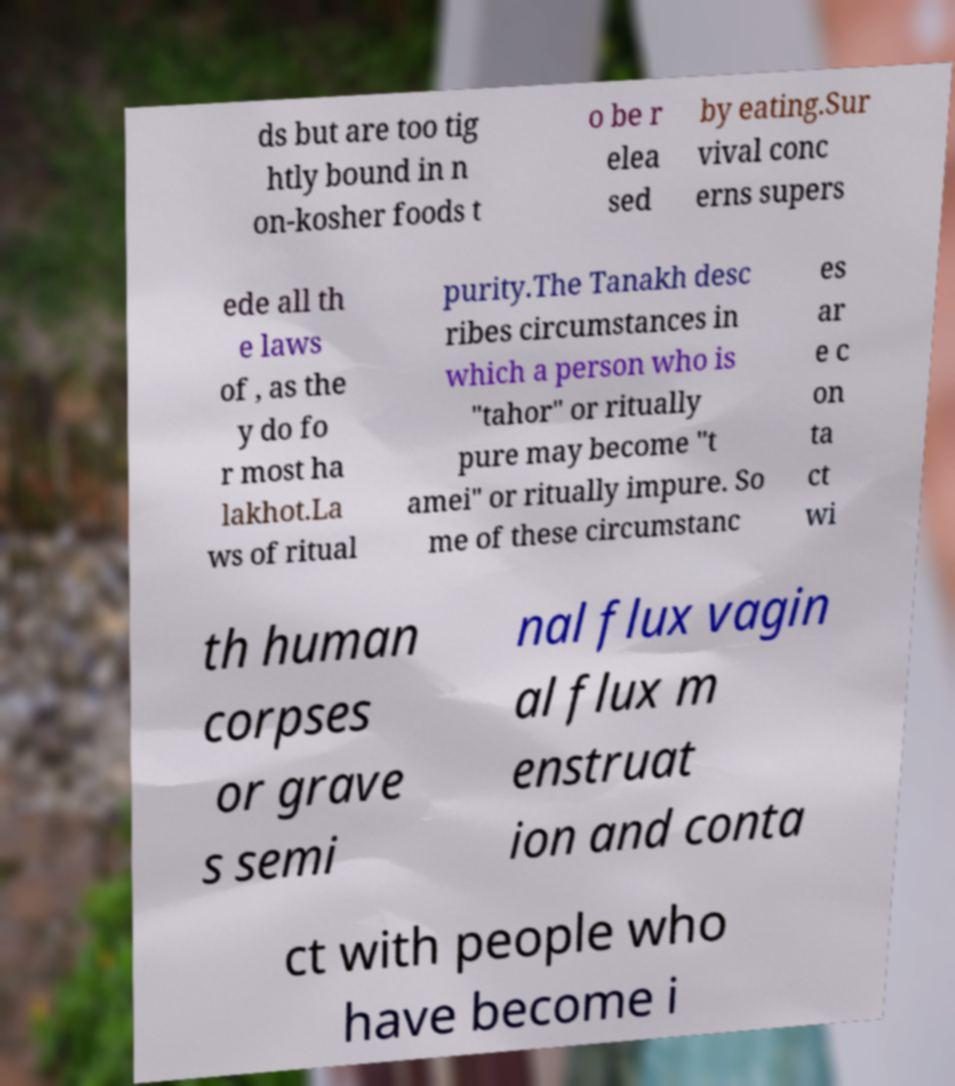I need the written content from this picture converted into text. Can you do that? ds but are too tig htly bound in n on-kosher foods t o be r elea sed by eating.Sur vival conc erns supers ede all th e laws of , as the y do fo r most ha lakhot.La ws of ritual purity.The Tanakh desc ribes circumstances in which a person who is "tahor" or ritually pure may become "t amei" or ritually impure. So me of these circumstanc es ar e c on ta ct wi th human corpses or grave s semi nal flux vagin al flux m enstruat ion and conta ct with people who have become i 